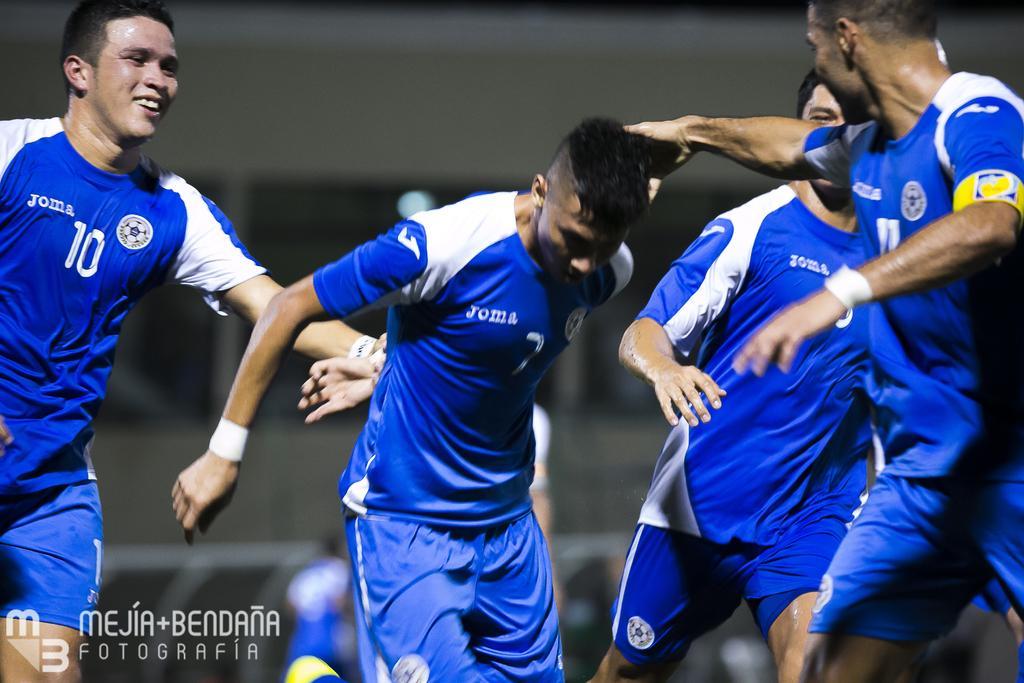In one or two sentences, can you explain what this image depicts? In this image I can see few people are standing and I can see all of them are wearing blue dress. I can also see few numbers are written on their dress. I can see this image is little bit blurry from background and here I can see watermark. 